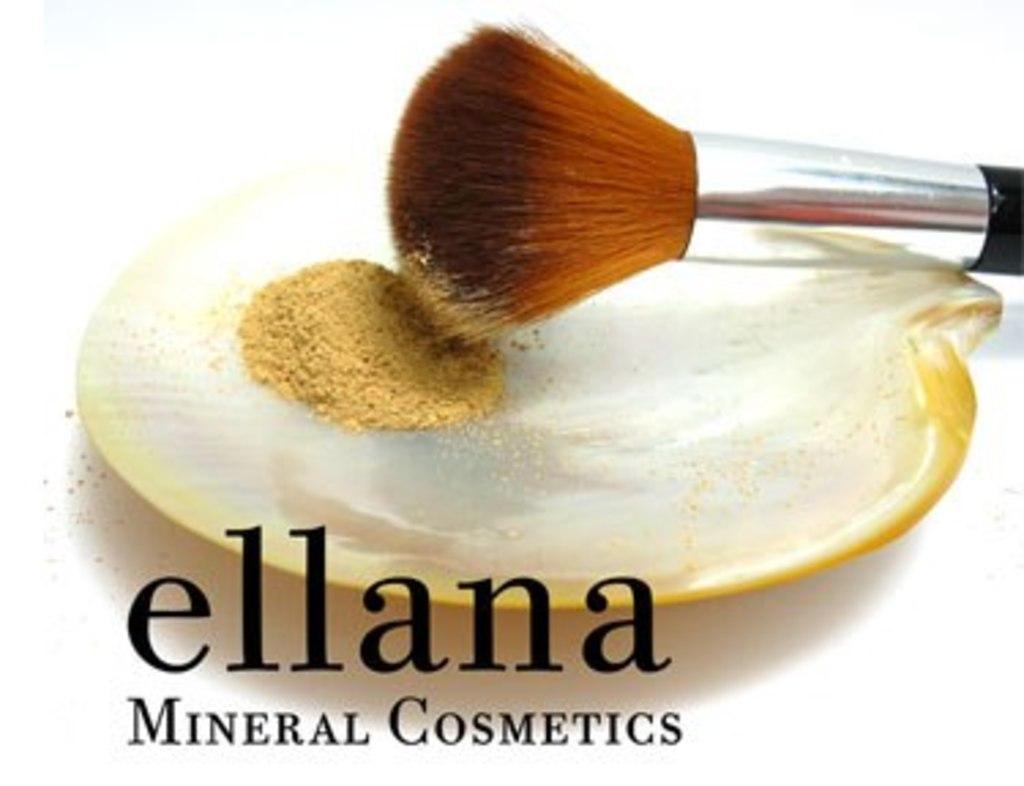What is the brand name of the cosmetics?
Provide a succinct answer. Ellana. What is the type of cosmetic?
Your answer should be compact. Mineral. 